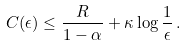Convert formula to latex. <formula><loc_0><loc_0><loc_500><loc_500>C ( \epsilon ) \leq \frac { R } { 1 - \alpha } + \kappa \log \frac { 1 } { \epsilon } \, .</formula> 